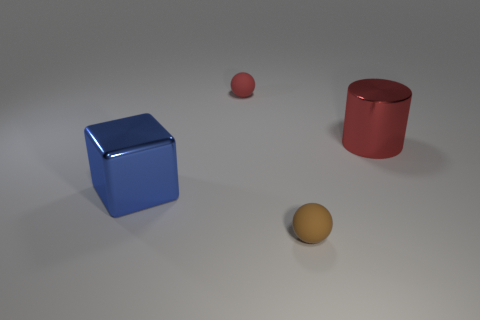Add 3 tiny brown matte objects. How many objects exist? 7 Subtract all cylinders. How many objects are left? 3 Subtract 1 spheres. How many spheres are left? 1 Add 2 cubes. How many cubes exist? 3 Subtract all red balls. How many balls are left? 1 Subtract 0 brown blocks. How many objects are left? 4 Subtract all cyan balls. Subtract all purple blocks. How many balls are left? 2 Subtract all small yellow metal balls. Subtract all brown rubber spheres. How many objects are left? 3 Add 1 large blue metal things. How many large blue metal things are left? 2 